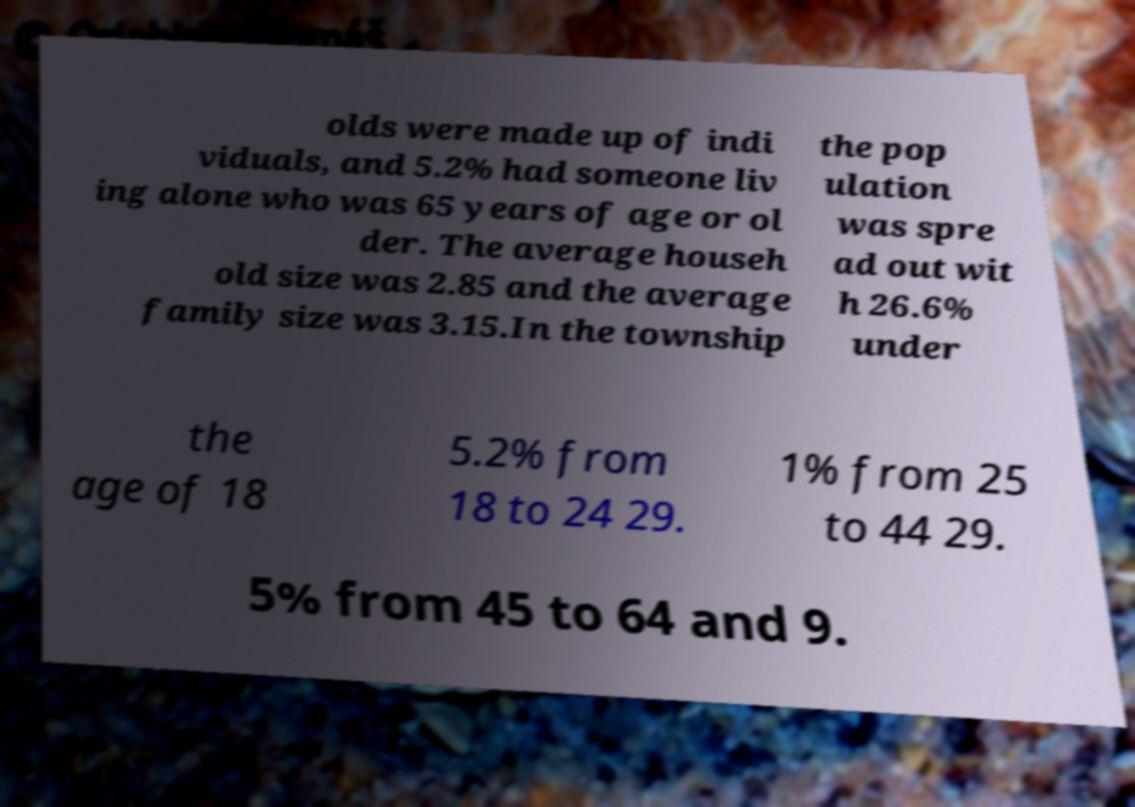Can you read and provide the text displayed in the image?This photo seems to have some interesting text. Can you extract and type it out for me? olds were made up of indi viduals, and 5.2% had someone liv ing alone who was 65 years of age or ol der. The average househ old size was 2.85 and the average family size was 3.15.In the township the pop ulation was spre ad out wit h 26.6% under the age of 18 5.2% from 18 to 24 29. 1% from 25 to 44 29. 5% from 45 to 64 and 9. 